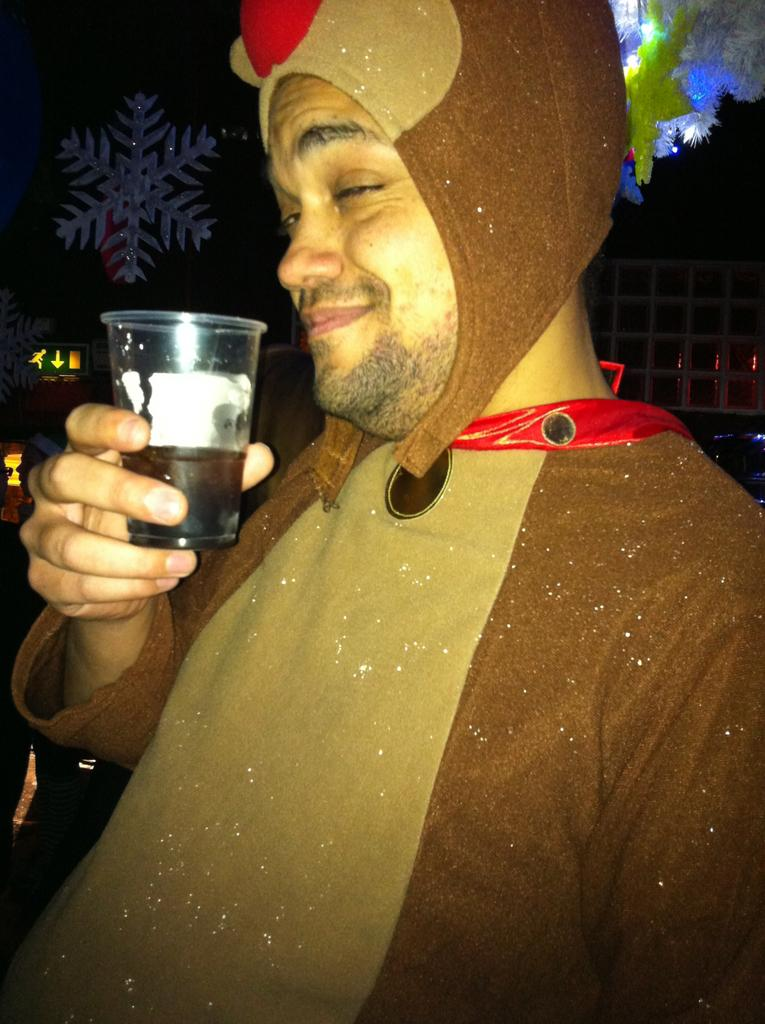What is the main subject of the image? There is a man in the image. What is the man wearing in the image? The man is wearing a costume in the image. What object is the man holding in the image? The man is holding a glass in the image. What type of flame can be seen coming from the man's costume in the image? There is no flame present in the image; the man is wearing a costume, but it does not involve any flames. 